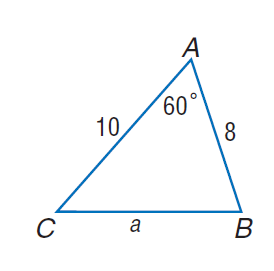Question: Find a if c = 8, b = 10, and m \angle A = 60.
Choices:
A. 4.6
B. 5.9
C. 7.2
D. 9.2
Answer with the letter. Answer: D 